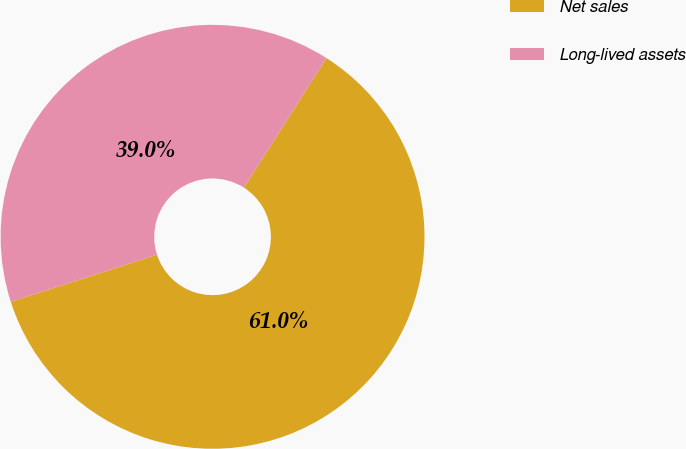Convert chart. <chart><loc_0><loc_0><loc_500><loc_500><pie_chart><fcel>Net sales<fcel>Long-lived assets<nl><fcel>61.0%<fcel>39.0%<nl></chart> 